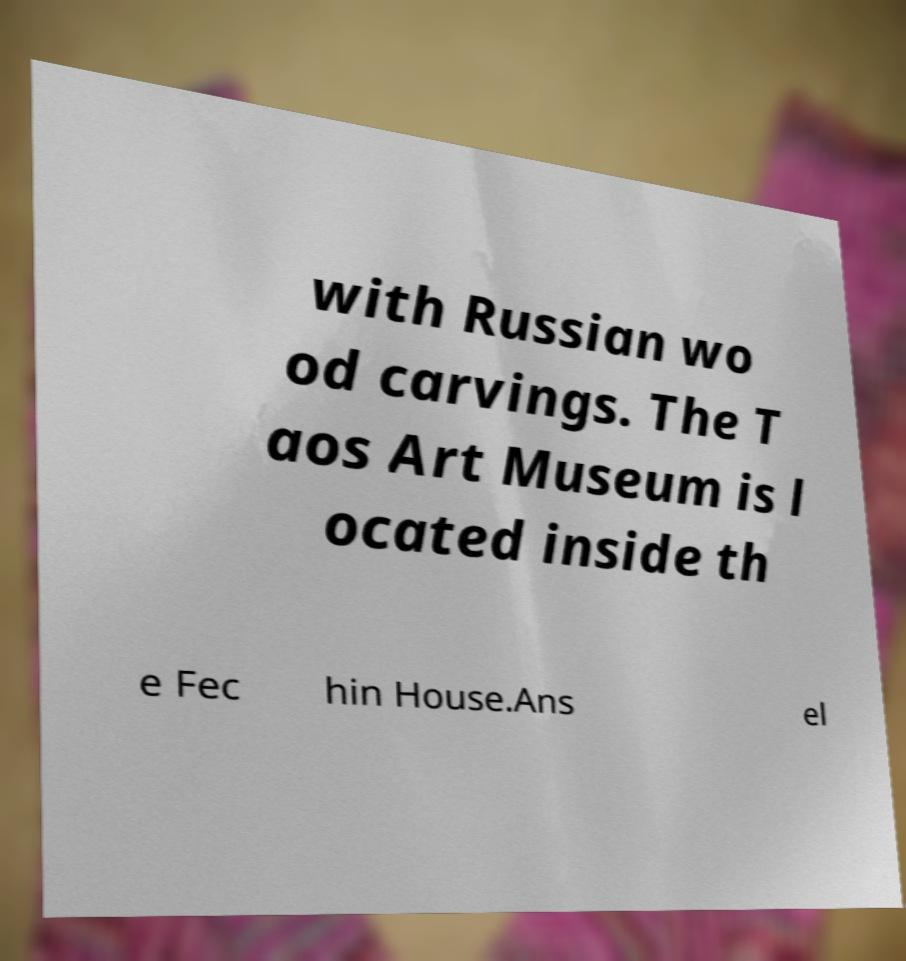Please read and relay the text visible in this image. What does it say? with Russian wo od carvings. The T aos Art Museum is l ocated inside th e Fec hin House.Ans el 